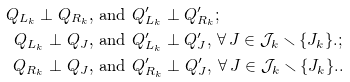<formula> <loc_0><loc_0><loc_500><loc_500>Q _ { L _ { k } } \perp Q _ { R _ { k } } & \text {, and } Q ^ { \prime } _ { L _ { k } } \perp Q ^ { \prime } _ { R _ { k } } ; \\ Q _ { L _ { k } } \perp Q _ { J } & \text {, and } Q ^ { \prime } _ { L _ { k } } \perp Q ^ { \prime } _ { J } , \, \forall \, J \in \mathcal { J } _ { k } \smallsetminus \{ J _ { k } \} . ; \\ Q _ { R _ { k } } \perp Q _ { J } & \text {, and } Q ^ { \prime } _ { R _ { k } } \perp Q ^ { \prime } _ { J } , \, \forall \, J \in \mathcal { J } _ { k } \smallsetminus \{ J _ { k } \} . .</formula> 